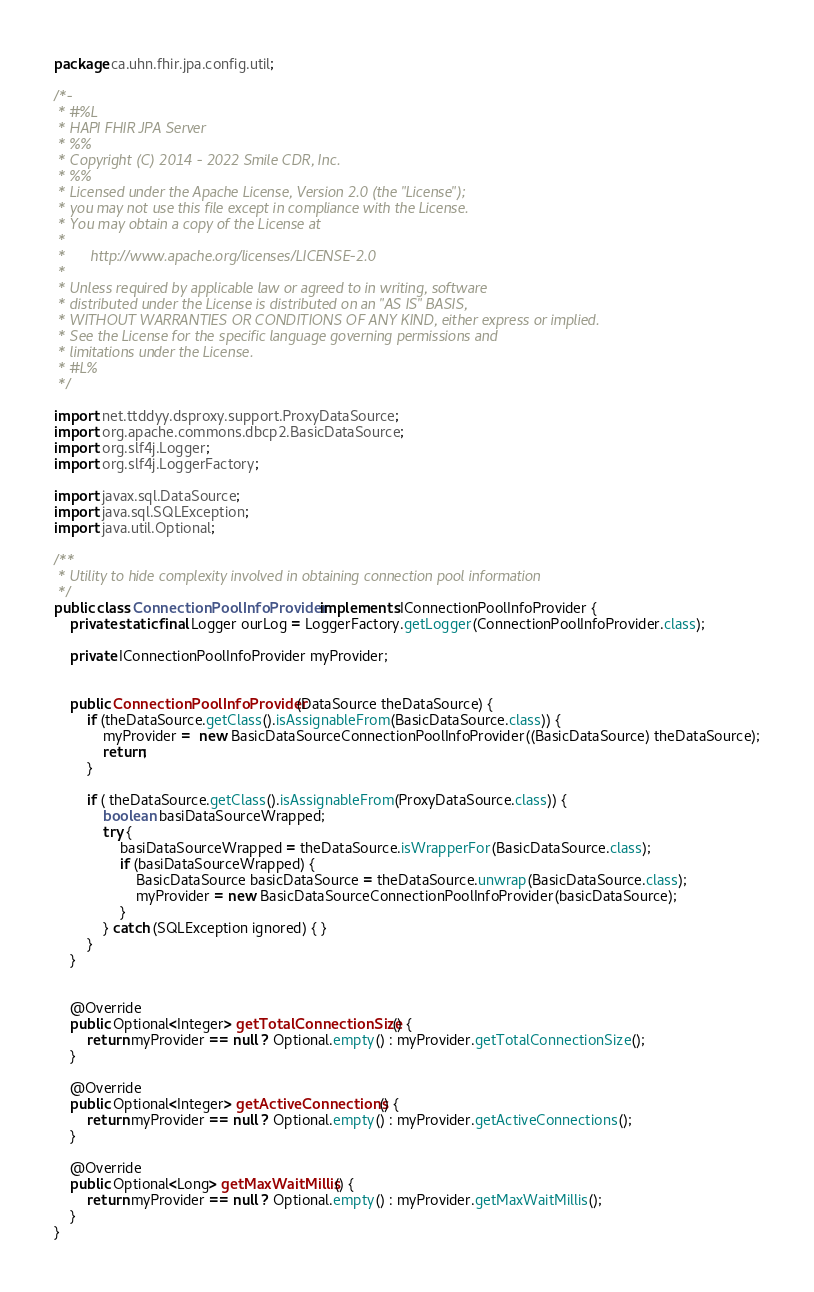Convert code to text. <code><loc_0><loc_0><loc_500><loc_500><_Java_>package ca.uhn.fhir.jpa.config.util;

/*-
 * #%L
 * HAPI FHIR JPA Server
 * %%
 * Copyright (C) 2014 - 2022 Smile CDR, Inc.
 * %%
 * Licensed under the Apache License, Version 2.0 (the "License");
 * you may not use this file except in compliance with the License.
 * You may obtain a copy of the License at
 *
 *      http://www.apache.org/licenses/LICENSE-2.0
 *
 * Unless required by applicable law or agreed to in writing, software
 * distributed under the License is distributed on an "AS IS" BASIS,
 * WITHOUT WARRANTIES OR CONDITIONS OF ANY KIND, either express or implied.
 * See the License for the specific language governing permissions and
 * limitations under the License.
 * #L%
 */

import net.ttddyy.dsproxy.support.ProxyDataSource;
import org.apache.commons.dbcp2.BasicDataSource;
import org.slf4j.Logger;
import org.slf4j.LoggerFactory;

import javax.sql.DataSource;
import java.sql.SQLException;
import java.util.Optional;

/**
 * Utility to hide complexity involved in obtaining connection pool information
 */
public class ConnectionPoolInfoProvider implements IConnectionPoolInfoProvider {
	private static final Logger ourLog = LoggerFactory.getLogger(ConnectionPoolInfoProvider.class);

	private IConnectionPoolInfoProvider myProvider;


	public ConnectionPoolInfoProvider(DataSource theDataSource) {
		if (theDataSource.getClass().isAssignableFrom(BasicDataSource.class)) {
			myProvider =  new BasicDataSourceConnectionPoolInfoProvider((BasicDataSource) theDataSource);
			return;
		}

		if ( theDataSource.getClass().isAssignableFrom(ProxyDataSource.class)) {
			boolean basiDataSourceWrapped;
			try {
				basiDataSourceWrapped = theDataSource.isWrapperFor(BasicDataSource.class);
				if (basiDataSourceWrapped) {
					BasicDataSource basicDataSource = theDataSource.unwrap(BasicDataSource.class);
					myProvider = new BasicDataSourceConnectionPoolInfoProvider(basicDataSource);
				}
			} catch (SQLException ignored) { }
		}
	}


	@Override
	public Optional<Integer> getTotalConnectionSize() {
		return myProvider == null ? Optional.empty() : myProvider.getTotalConnectionSize();
	}

	@Override
	public Optional<Integer> getActiveConnections() {
		return myProvider == null ? Optional.empty() : myProvider.getActiveConnections();
	}

	@Override
	public Optional<Long> getMaxWaitMillis() {
		return myProvider == null ? Optional.empty() : myProvider.getMaxWaitMillis();
	}
}



</code> 